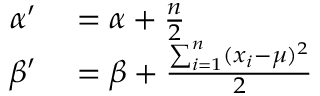<formula> <loc_0><loc_0><loc_500><loc_500>\begin{array} { r l } { \alpha ^ { \prime } } & = \alpha + { \frac { n } { 2 } } } \\ { \beta ^ { \prime } } & = \beta + { \frac { \sum _ { i = 1 } ^ { n } ( x _ { i } - \mu ) ^ { 2 } } { 2 } } } \end{array}</formula> 